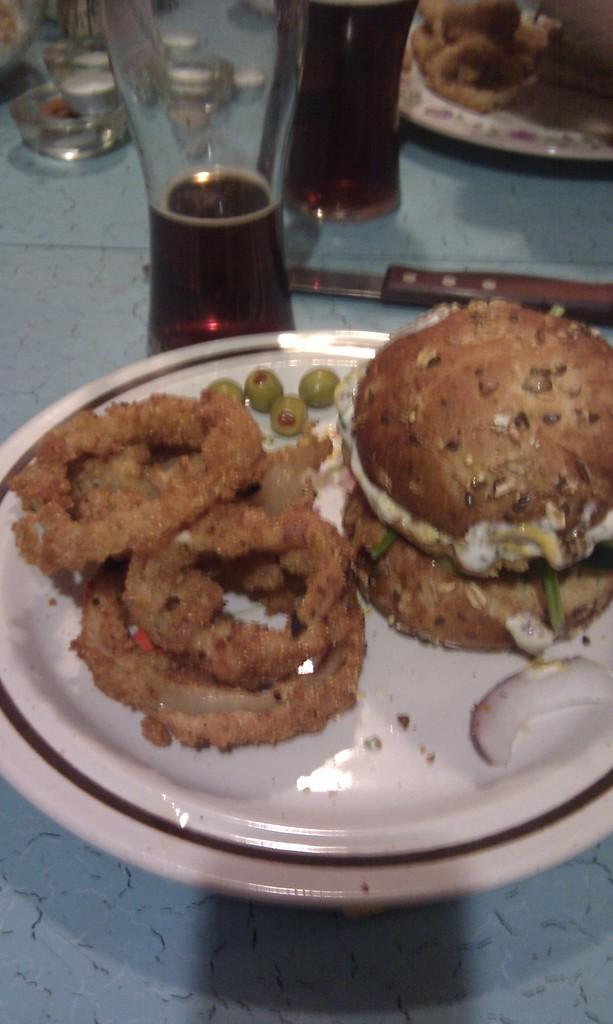What is on the plates that are visible in the image? There are plates with food in the image. What is the color of the surface on which the plates are placed? The plates are placed on a blue surface. What is inside the glasses that are visible in the image? There are glasses with liquid in the image. What other objects can be seen in the image besides the plates and glasses? To produce the conversation, we first identify the main subjects in the image, which are the plates with food and the glasses with liquid. We then describe the color of the surface on which the plates are placed and mention the presence of a knife. Each question is designed to elicit a specific detail about the image that is known from the provided facts. Absurd Question/Answer: What type of stocking is hanging from the ceiling in the image? There is no stocking hanging from the ceiling in the image. What type of juice is being served in the glasses in the image? There is no information about the type of liquid in the glasses, so we cannot determine if it is juice or not. 